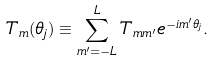Convert formula to latex. <formula><loc_0><loc_0><loc_500><loc_500>T _ { m } ( \theta _ { j } ) \equiv \sum _ { m ^ { \prime } = - L } ^ { L } T _ { m m ^ { \prime } } e ^ { - i m ^ { \prime } \theta _ { j } } .</formula> 